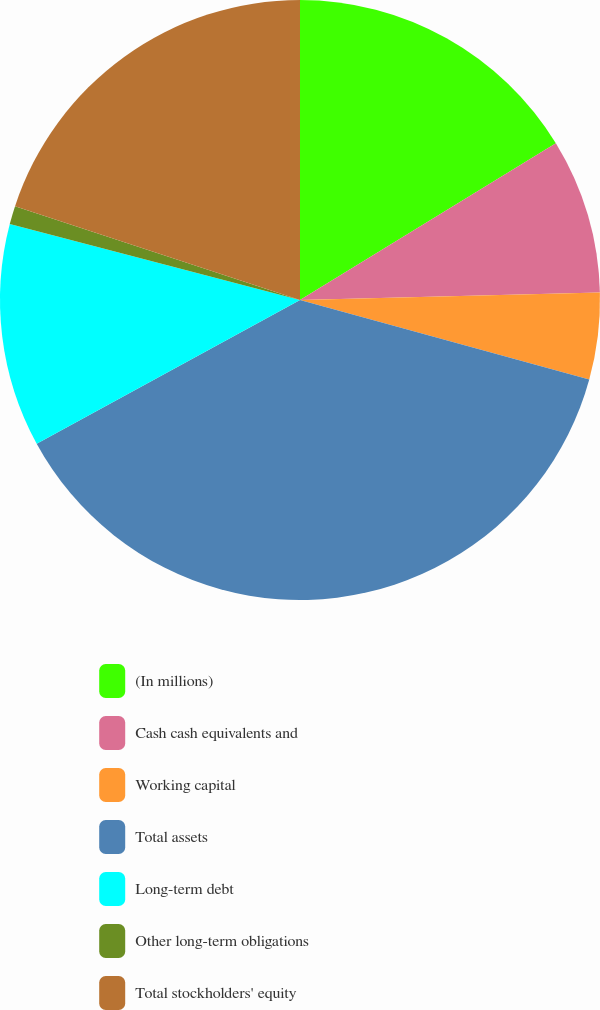Convert chart to OTSL. <chart><loc_0><loc_0><loc_500><loc_500><pie_chart><fcel>(In millions)<fcel>Cash cash equivalents and<fcel>Working capital<fcel>Total assets<fcel>Long-term debt<fcel>Other long-term obligations<fcel>Total stockholders' equity<nl><fcel>16.26%<fcel>8.35%<fcel>4.67%<fcel>37.78%<fcel>12.03%<fcel>0.99%<fcel>19.94%<nl></chart> 